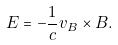<formula> <loc_0><loc_0><loc_500><loc_500>E = - \frac { 1 } { c } v _ { B } \times B .</formula> 